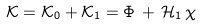<formula> <loc_0><loc_0><loc_500><loc_500>\mathcal { K } = \mathcal { K } _ { 0 } + \mathcal { K } _ { 1 } = \Phi \, + \, \mathcal { H } _ { 1 } \, \chi</formula> 